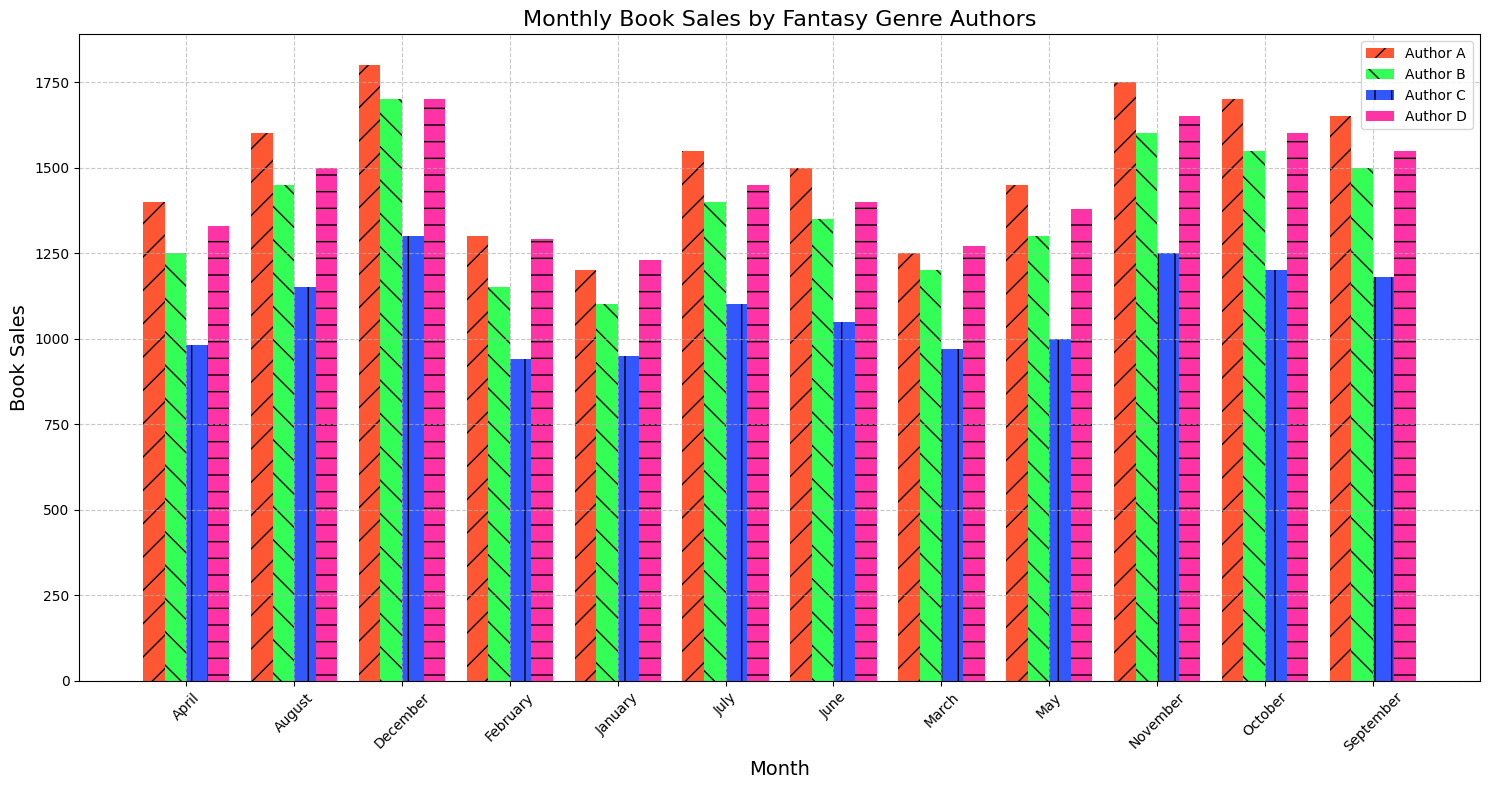Which author had the highest monthly book sales? By looking at the highest bar for each month, we observe that Author A consistently has the tallest bars every month. Specifically, Author A peaks at 1800 book sales in December.
Answer: Author A Which month had the lowest book sales for Author C? By scanning through the bars for Author C, identified by a consistent color/pattern, the shortest bar for Author C appears in February with sales of 940.
Answer: February How do the total book sales of Author A compare to Author B across the entire year? Adding up the monthly sales for both authors:
- Author A: 1200 + 1300 + 1250 + 1400 + 1450 + 1500 + 1550 + 1600 + 1650 + 1700 + 1750 + 1800 = 18650
- Author B: 1100 + 1150 + 1200 + 1250 + 1300 + 1350 + 1400 + 1450 + 1500 + 1550 + 1600 + 1700 = 16950 
Author A's total is 18650, which is higher than Author B's total of 16950.
Answer: Author A has higher total sales Which month had the biggest difference in book sales between Author A and Author D? Calculate the absolute difference in book sales for each month. December has the largest difference with Author A at 1800 sales and Author D at 1700, yielding a difference of 100.
Answer: December Which author had the steadiest increase in book sales over the year? Plot the trend line visually by looking for consistent growth month-to-month. Author B shows a steady and gradual increase.
Answer: Author B Between July and December, how did sales change for Author C? Compare the height of the bars for Author C between July (1100) and December (1300). There is an increase from 1100 to 1300 sales.
Answer: Increased from 1100 to 1300 What is the overall trend in book sales for Author D throughout the year? Observe the pattern of the bars for Author D, which shows a generally increasing trend.
Answer: Increasing trend Among all authors, whose books showed the sharpest increase in sales in a single month? Identify the month with the largest month-to-month difference for each author. Author A shows the largest increase from November (1750) to December (1800), a difference of 50 sales.
Answer: Author A 